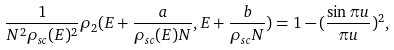Convert formula to latex. <formula><loc_0><loc_0><loc_500><loc_500>\frac { 1 } { N ^ { 2 } \rho _ { s c } ( E ) ^ { 2 } } \rho _ { 2 } ( E + \frac { a } { \rho _ { s c } ( E ) N } , E + \frac { b } { \rho _ { s c } N } ) = 1 - ( \frac { \sin \pi u } { \pi u } ) ^ { 2 } ,</formula> 